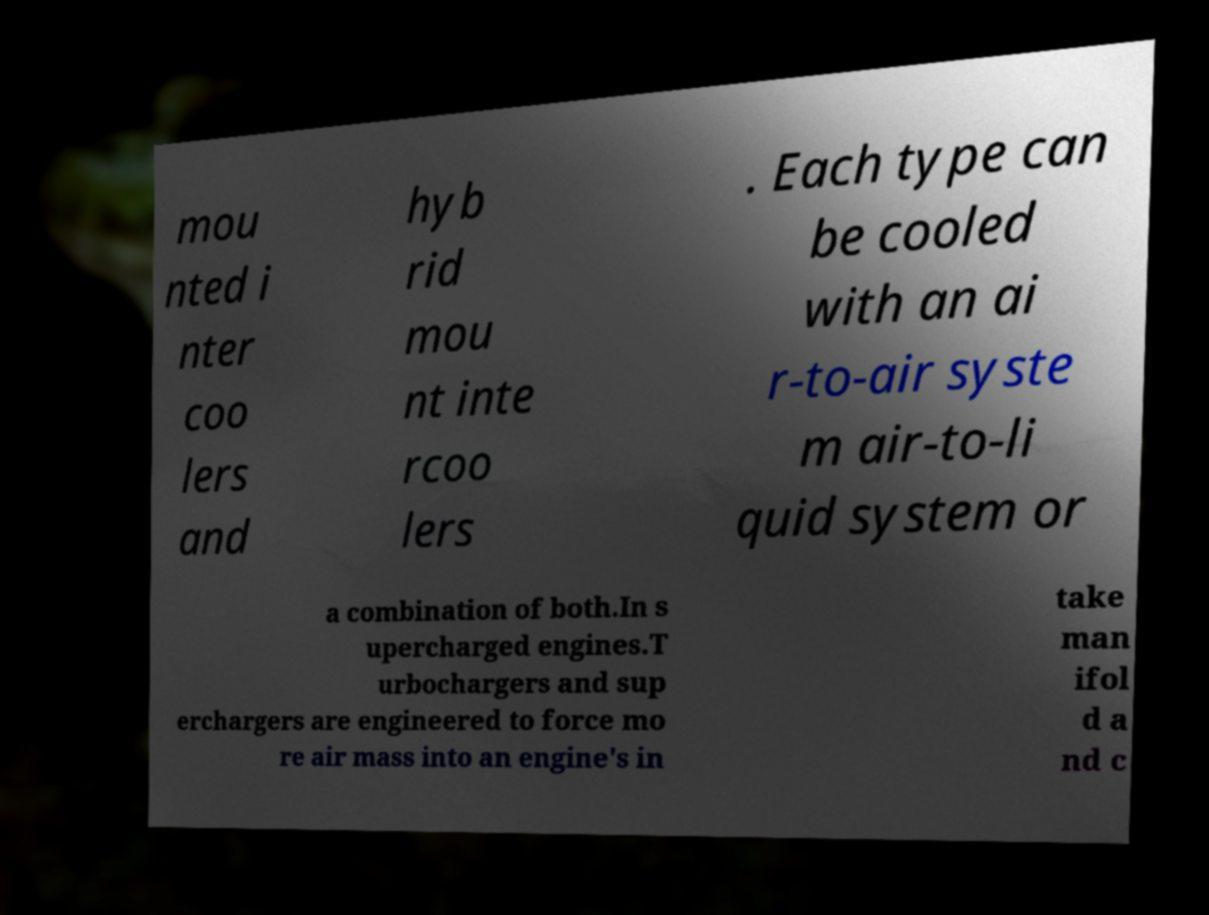Could you extract and type out the text from this image? mou nted i nter coo lers and hyb rid mou nt inte rcoo lers . Each type can be cooled with an ai r-to-air syste m air-to-li quid system or a combination of both.In s upercharged engines.T urbochargers and sup erchargers are engineered to force mo re air mass into an engine's in take man ifol d a nd c 